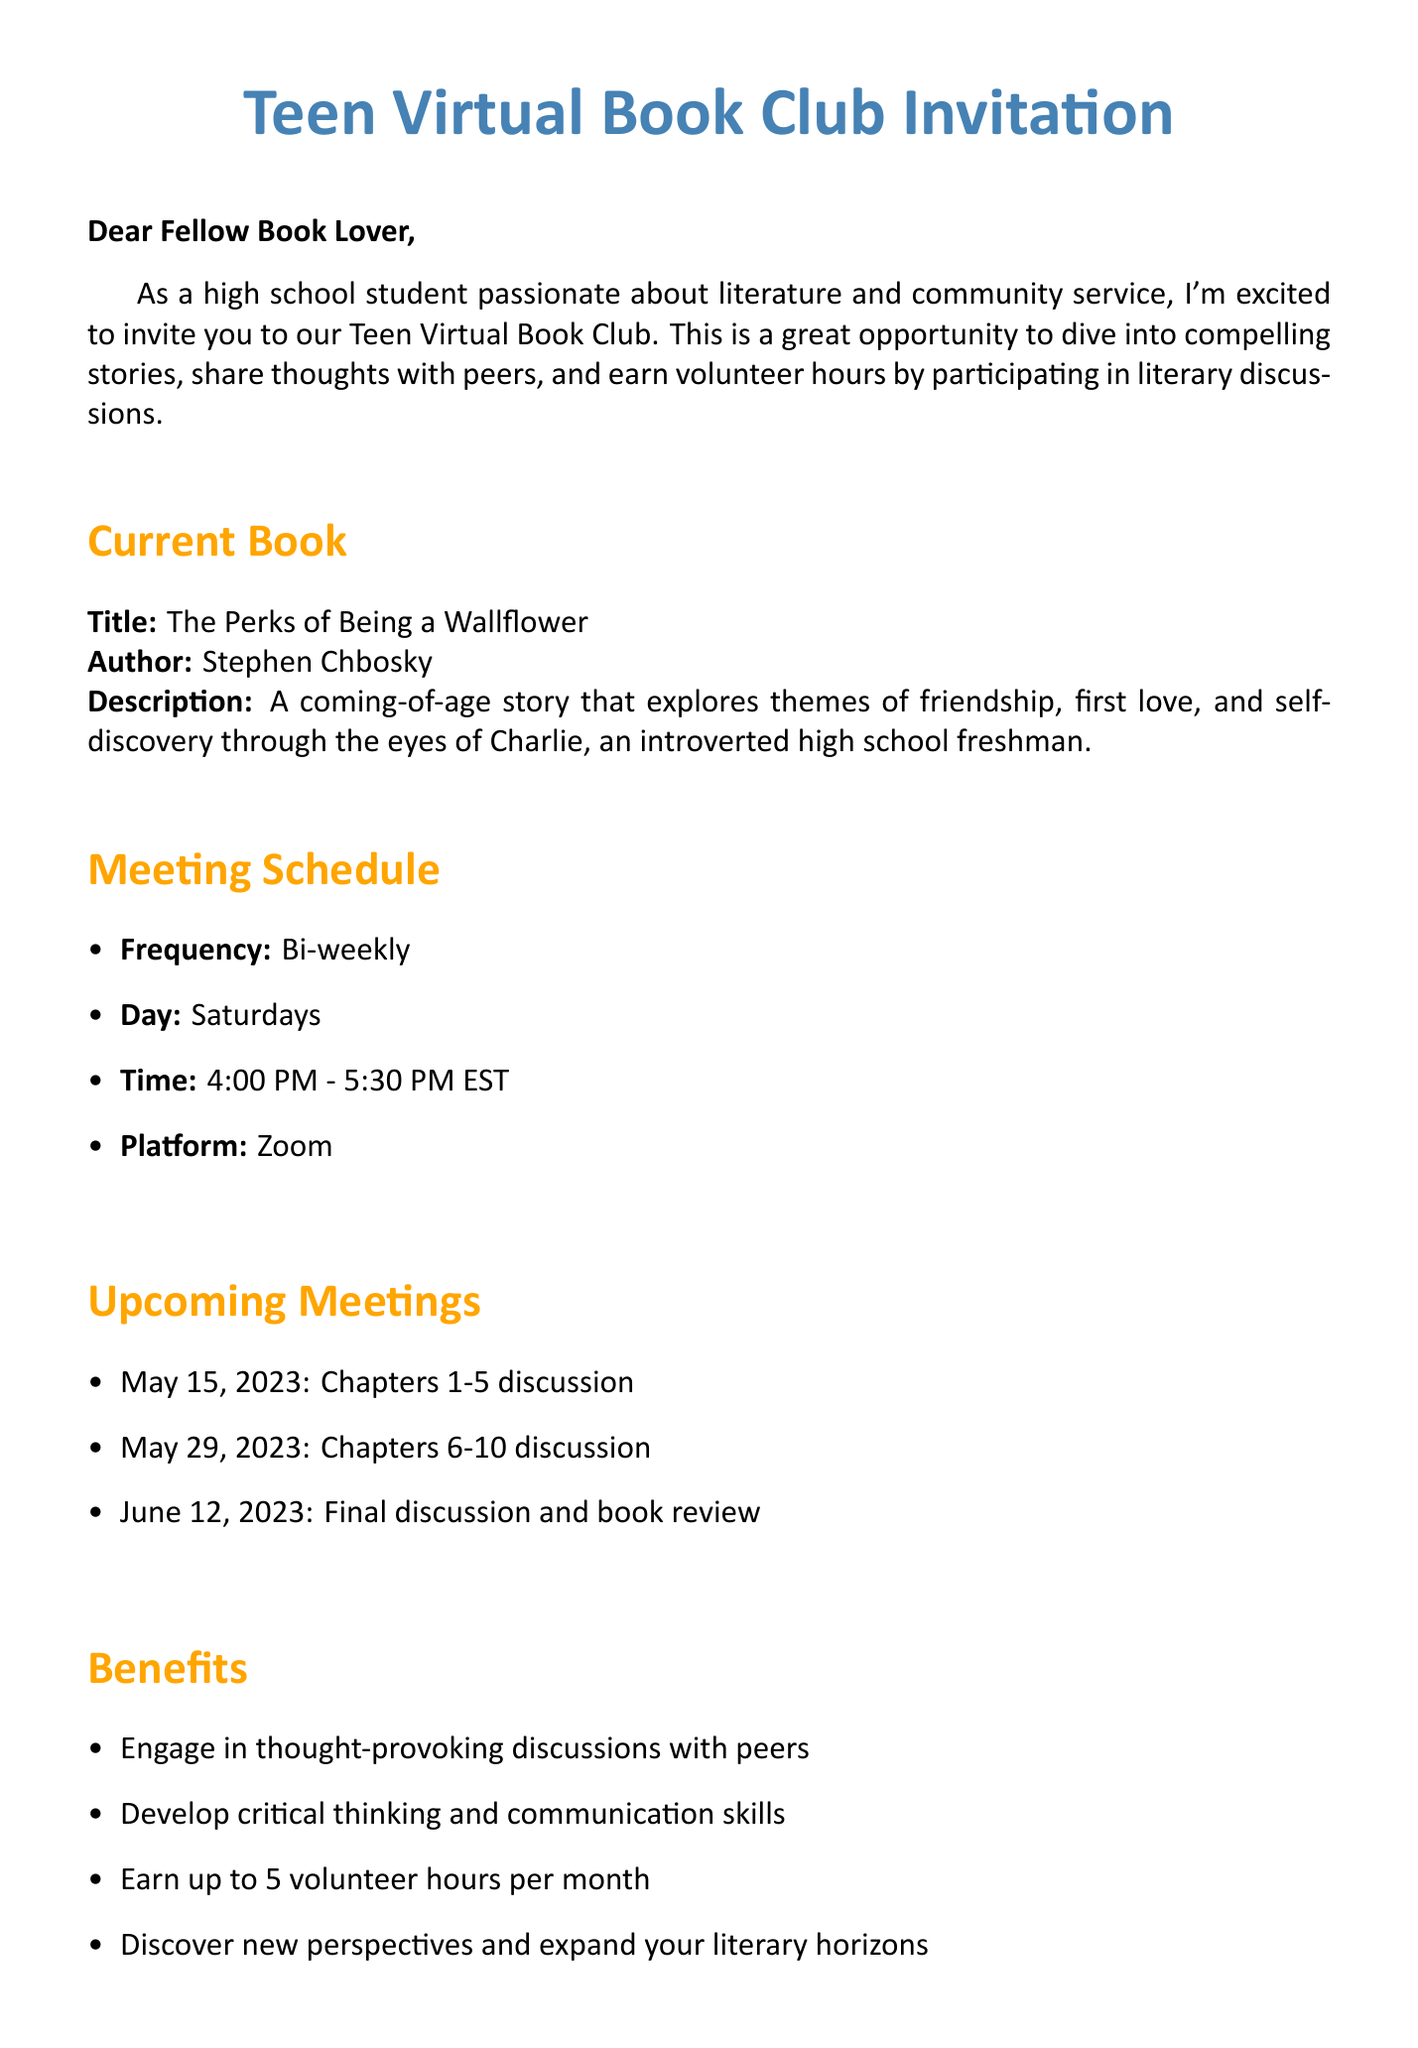What is the title of the current book? The title of the current book is specified in the document.
Answer: The Perks of Being a Wallflower Who is the author of the current book? The document provides the name of the author of the current book.
Answer: Stephen Chbosky What day do the meetings occur? The document states the specific day of the week when meetings take place.
Answer: Saturdays How often do the meetings happen? The frequency of the meetings is mentioned in the document.
Answer: Bi-weekly What time do the meetings start? The document specifies the time when meetings begin.
Answer: 4:00 PM How many volunteer hours can be earned per month? The document mentions the maximum number of volunteer hours participants can earn.
Answer: 5 What platform is used for the meetings? The document indicates the platform used for the virtual book club meetings.
Answer: Zoom What is the focus of the meeting on May 29, 2023? The document lists the specific focus for that date's meeting.
Answer: Chapters 6-10 discussion What should you provide to join the book club? The document outlines what information is required to join the book club.
Answer: Name, age, and school 